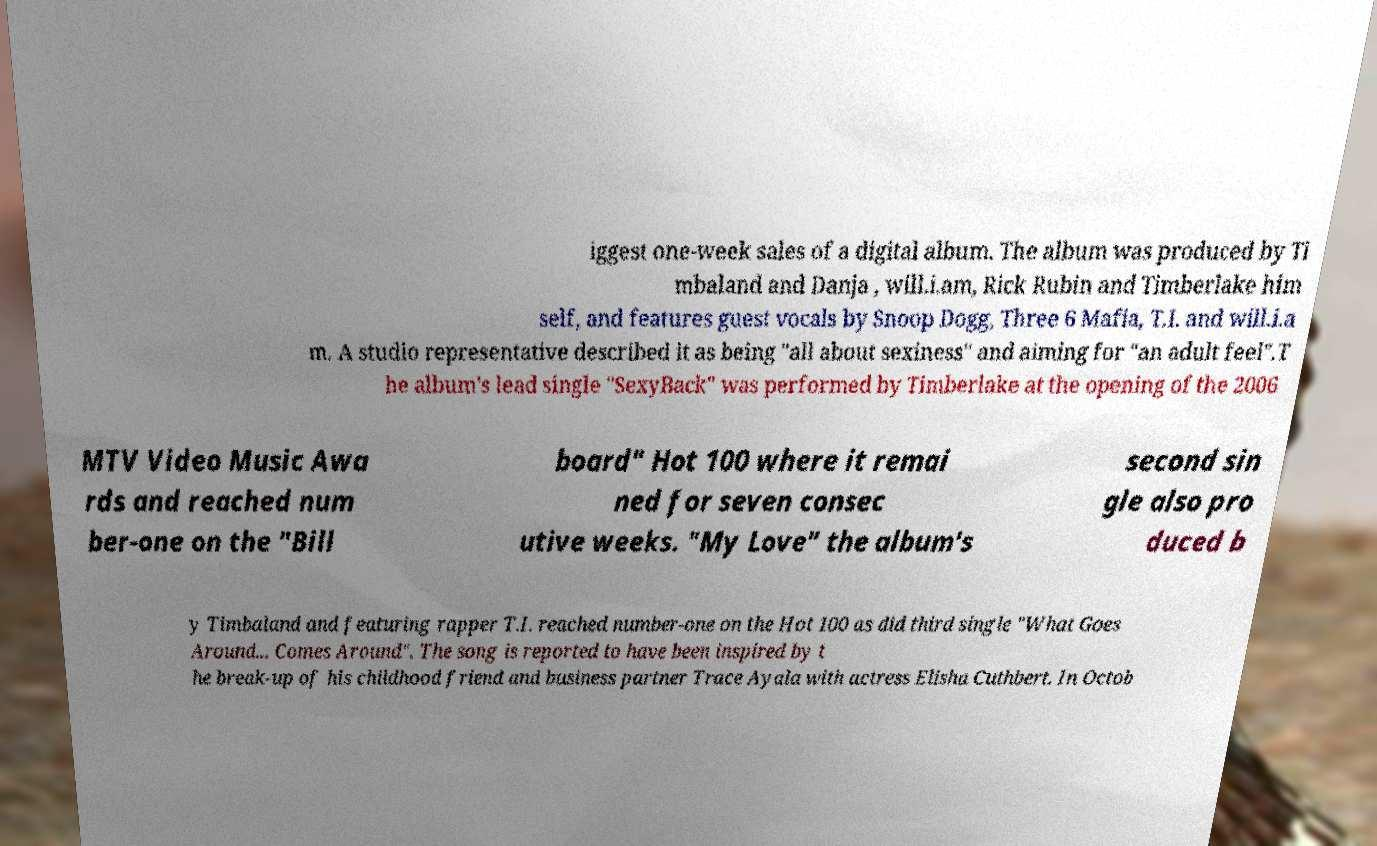I need the written content from this picture converted into text. Can you do that? iggest one-week sales of a digital album. The album was produced by Ti mbaland and Danja , will.i.am, Rick Rubin and Timberlake him self, and features guest vocals by Snoop Dogg, Three 6 Mafia, T.I. and will.i.a m. A studio representative described it as being "all about sexiness" and aiming for "an adult feel".T he album's lead single "SexyBack" was performed by Timberlake at the opening of the 2006 MTV Video Music Awa rds and reached num ber-one on the "Bill board" Hot 100 where it remai ned for seven consec utive weeks. "My Love" the album's second sin gle also pro duced b y Timbaland and featuring rapper T.I. reached number-one on the Hot 100 as did third single "What Goes Around... Comes Around". The song is reported to have been inspired by t he break-up of his childhood friend and business partner Trace Ayala with actress Elisha Cuthbert. In Octob 